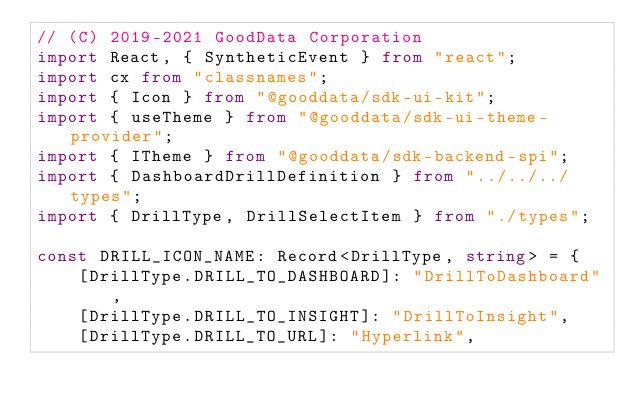<code> <loc_0><loc_0><loc_500><loc_500><_TypeScript_>// (C) 2019-2021 GoodData Corporation
import React, { SyntheticEvent } from "react";
import cx from "classnames";
import { Icon } from "@gooddata/sdk-ui-kit";
import { useTheme } from "@gooddata/sdk-ui-theme-provider";
import { ITheme } from "@gooddata/sdk-backend-spi";
import { DashboardDrillDefinition } from "../../../types";
import { DrillType, DrillSelectItem } from "./types";

const DRILL_ICON_NAME: Record<DrillType, string> = {
    [DrillType.DRILL_TO_DASHBOARD]: "DrillToDashboard",
    [DrillType.DRILL_TO_INSIGHT]: "DrillToInsight",
    [DrillType.DRILL_TO_URL]: "Hyperlink",</code> 